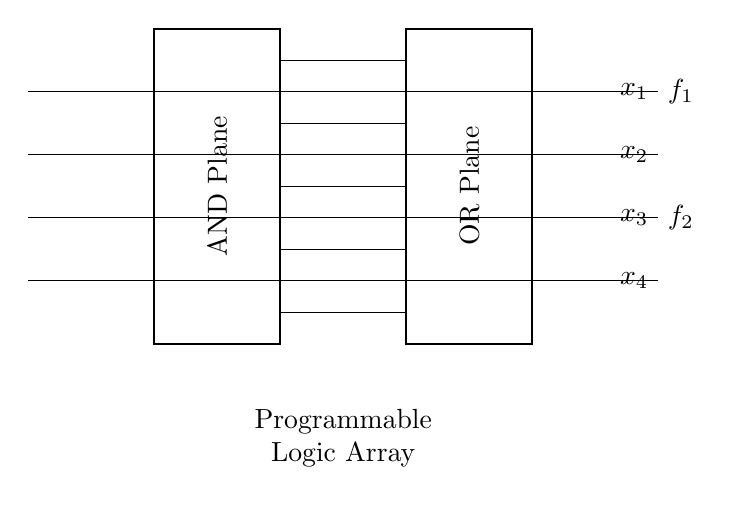What are the input variables for this PLA? The input variables are x1, x2, x3, and x4, as shown by the lines entering the AND plane.
Answer: x1, x2, x3, x4 How many outputs does this circuit have? The diagram shows that there are two outputs, f1 and f2, which are indicated on the right side of the OR plane.
Answer: 2 What type of logic function does the AND plane perform? The AND plane is responsible for performing logical AND operations among the input variables to create intermediate outputs that will be processed in the OR plane.
Answer: AND What connections can be seen between the planes? The connections running from the AND plane to the OR plane indicate how the outputs of the AND operations are fed into the OR operations to produce the final outputs.
Answer: Four connections What is the function of the OR Plane in this circuit? The OR plane combines the outputs from the AND plane to produce the final output functions, indicated as f1 and f2.
Answer: Combine What is the significance of the rectangle shapes drawn? The rectangles represent the AND and OR planes, which are critical components of a programmable logic array used to execute Boolean functions.
Answer: Logical planes 